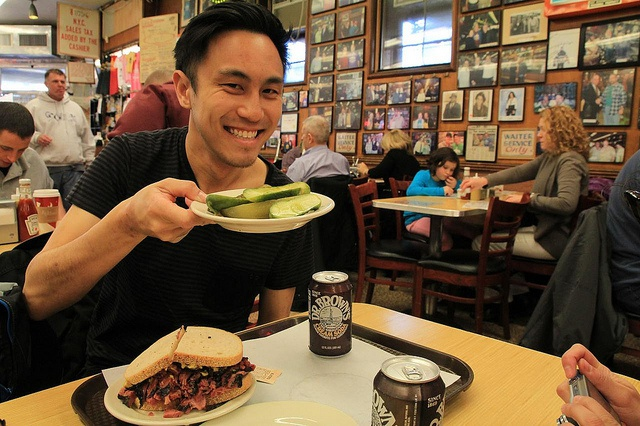Describe the objects in this image and their specific colors. I can see people in white, black, brown, tan, and maroon tones, dining table in white, orange, tan, and olive tones, people in white, black, maroon, and brown tones, sandwich in white, tan, black, maroon, and brown tones, and chair in white, black, maroon, and gray tones in this image. 